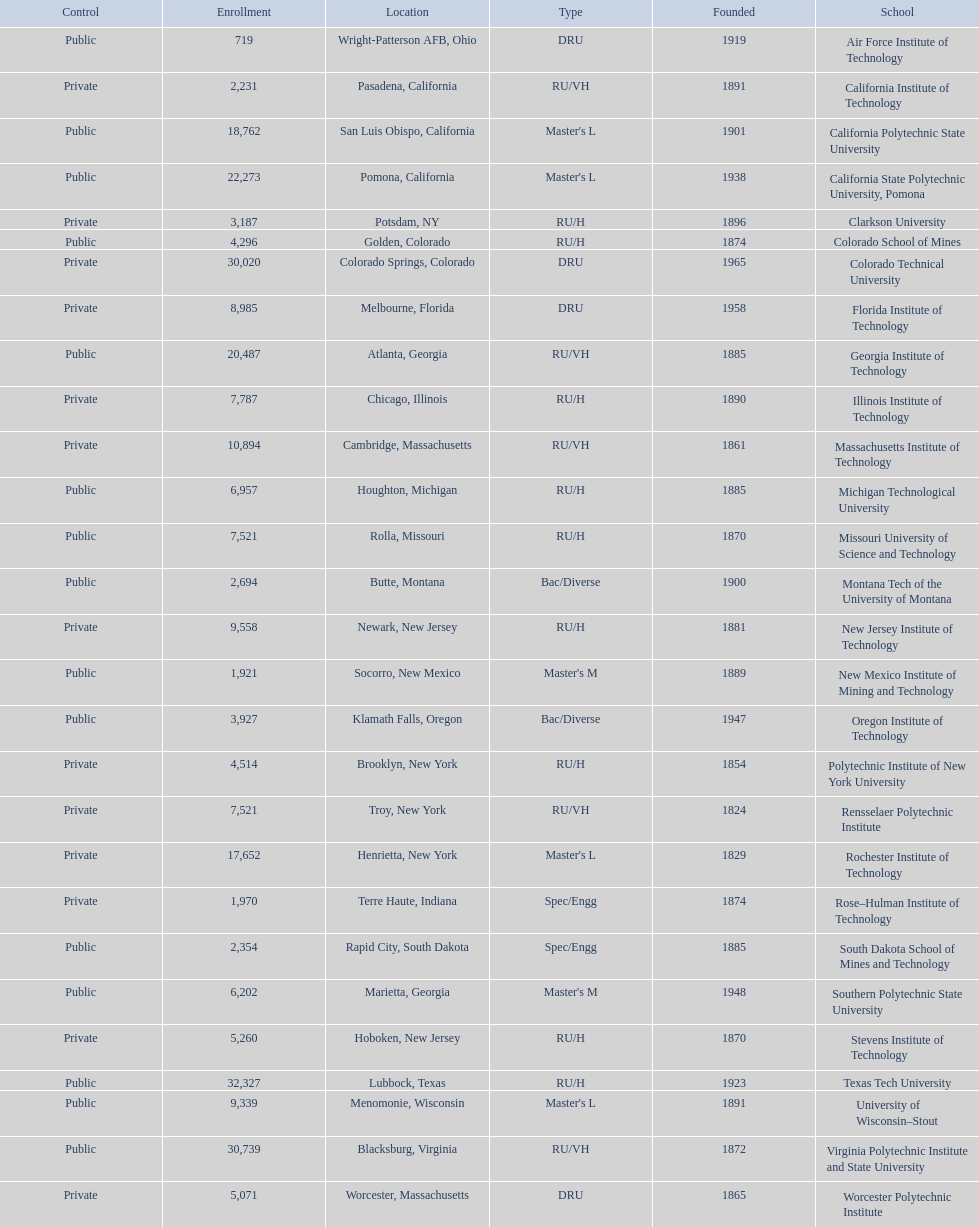What are all the schools? Air Force Institute of Technology, California Institute of Technology, California Polytechnic State University, California State Polytechnic University, Pomona, Clarkson University, Colorado School of Mines, Colorado Technical University, Florida Institute of Technology, Georgia Institute of Technology, Illinois Institute of Technology, Massachusetts Institute of Technology, Michigan Technological University, Missouri University of Science and Technology, Montana Tech of the University of Montana, New Jersey Institute of Technology, New Mexico Institute of Mining and Technology, Oregon Institute of Technology, Polytechnic Institute of New York University, Rensselaer Polytechnic Institute, Rochester Institute of Technology, Rose–Hulman Institute of Technology, South Dakota School of Mines and Technology, Southern Polytechnic State University, Stevens Institute of Technology, Texas Tech University, University of Wisconsin–Stout, Virginia Polytechnic Institute and State University, Worcester Polytechnic Institute. What is the enrollment of each school? 719, 2,231, 18,762, 22,273, 3,187, 4,296, 30,020, 8,985, 20,487, 7,787, 10,894, 6,957, 7,521, 2,694, 9,558, 1,921, 3,927, 4,514, 7,521, 17,652, 1,970, 2,354, 6,202, 5,260, 32,327, 9,339, 30,739, 5,071. And which school had the highest enrollment? Texas Tech University. 